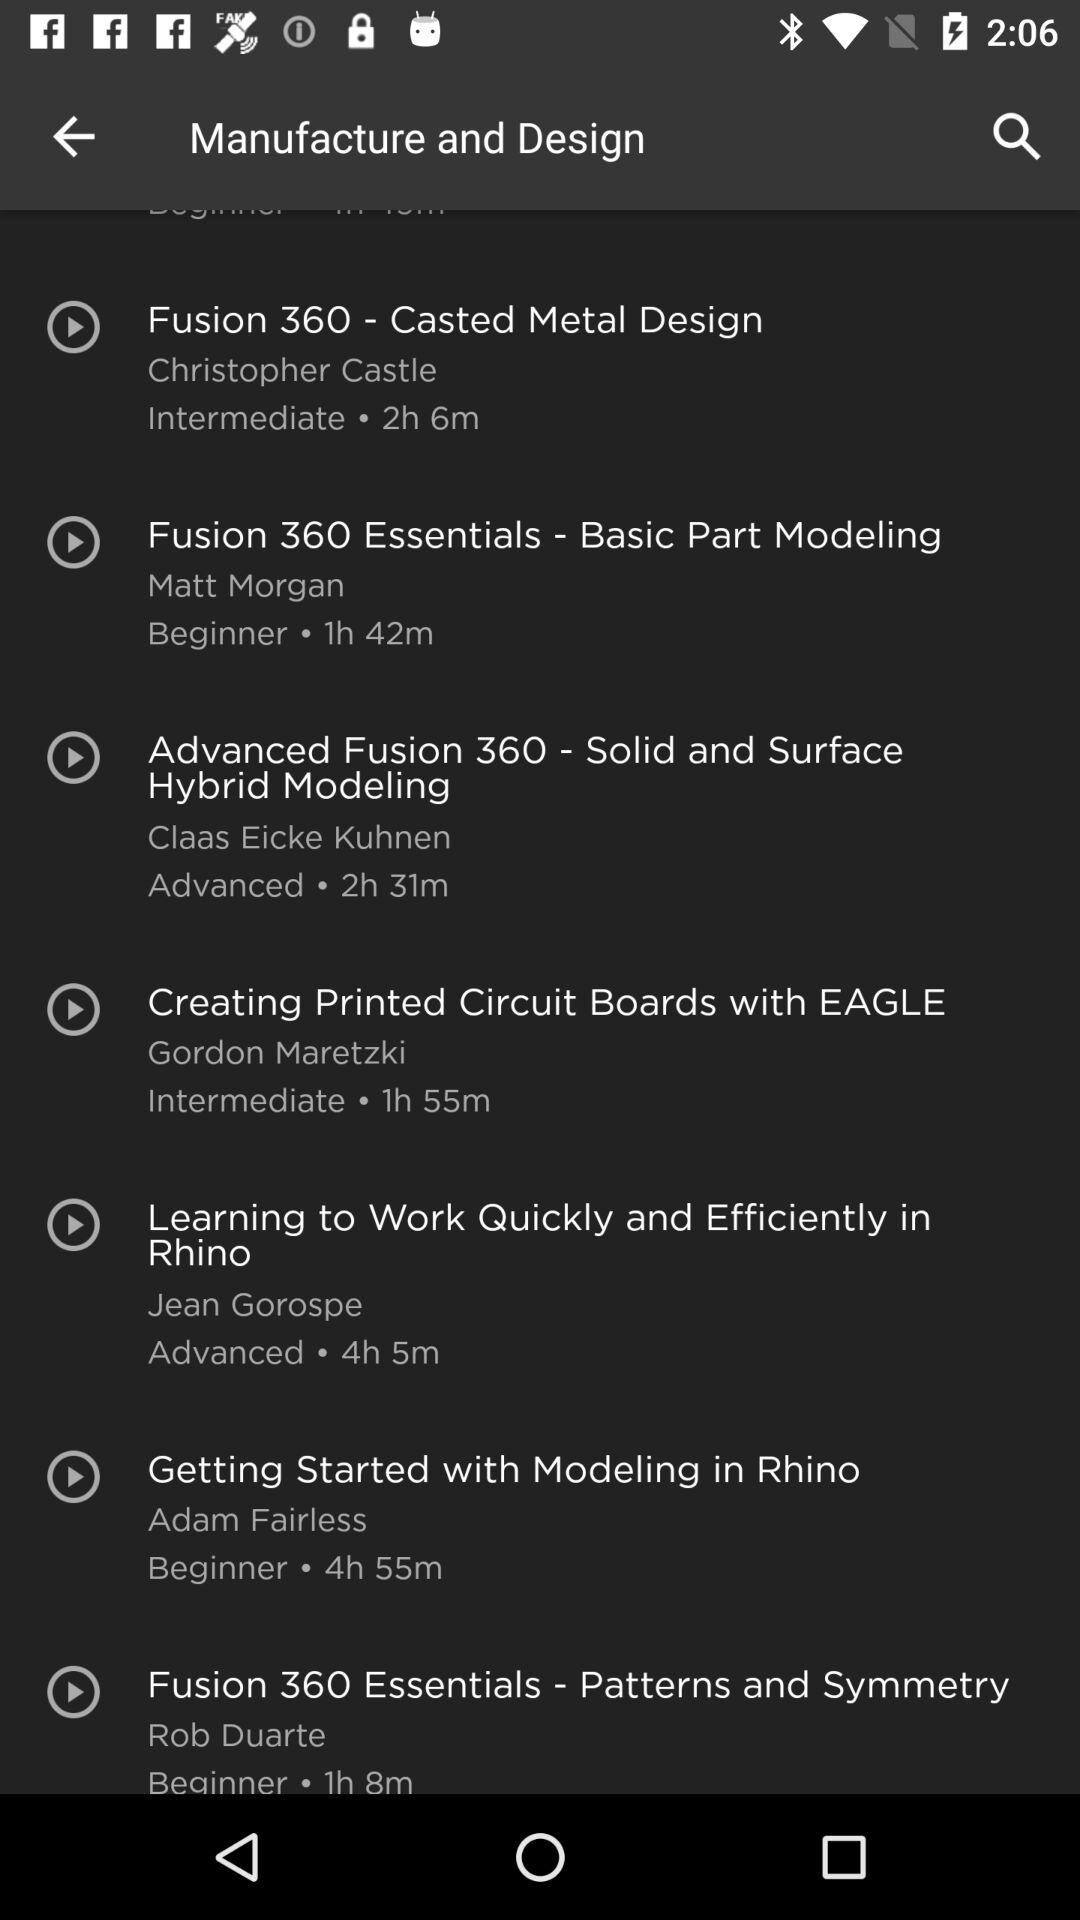What is the level of the course whose instructor is Adam Fairless? The level of the course is beginner. 